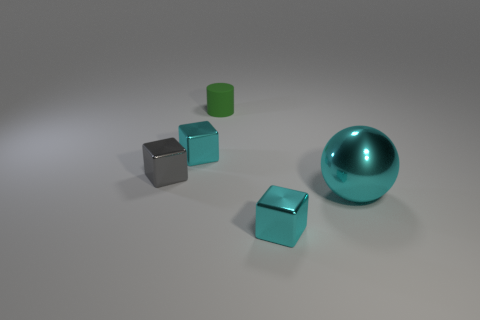There is a big thing; is its color the same as the tiny block that is to the right of the green rubber cylinder?
Offer a very short reply. Yes. What number of tiny cyan blocks are there?
Your answer should be compact. 2. What number of objects are either red metal cubes or large cyan spheres?
Give a very brief answer. 1. Are there any objects behind the cyan ball?
Ensure brevity in your answer.  Yes. Is the number of small green cylinders that are on the right side of the small gray metal thing greater than the number of tiny green things in front of the large cyan metallic sphere?
Your response must be concise. Yes. How many cubes are either gray objects or small brown things?
Make the answer very short. 1. Are there fewer green rubber things left of the tiny green matte cylinder than rubber objects right of the gray object?
Your answer should be compact. Yes. How many objects are either small things to the left of the tiny green rubber cylinder or green cylinders?
Make the answer very short. 3. The small cyan thing on the right side of the cyan object left of the cylinder is what shape?
Ensure brevity in your answer.  Cube. Are there any cyan metallic blocks of the same size as the green object?
Your answer should be compact. Yes. 